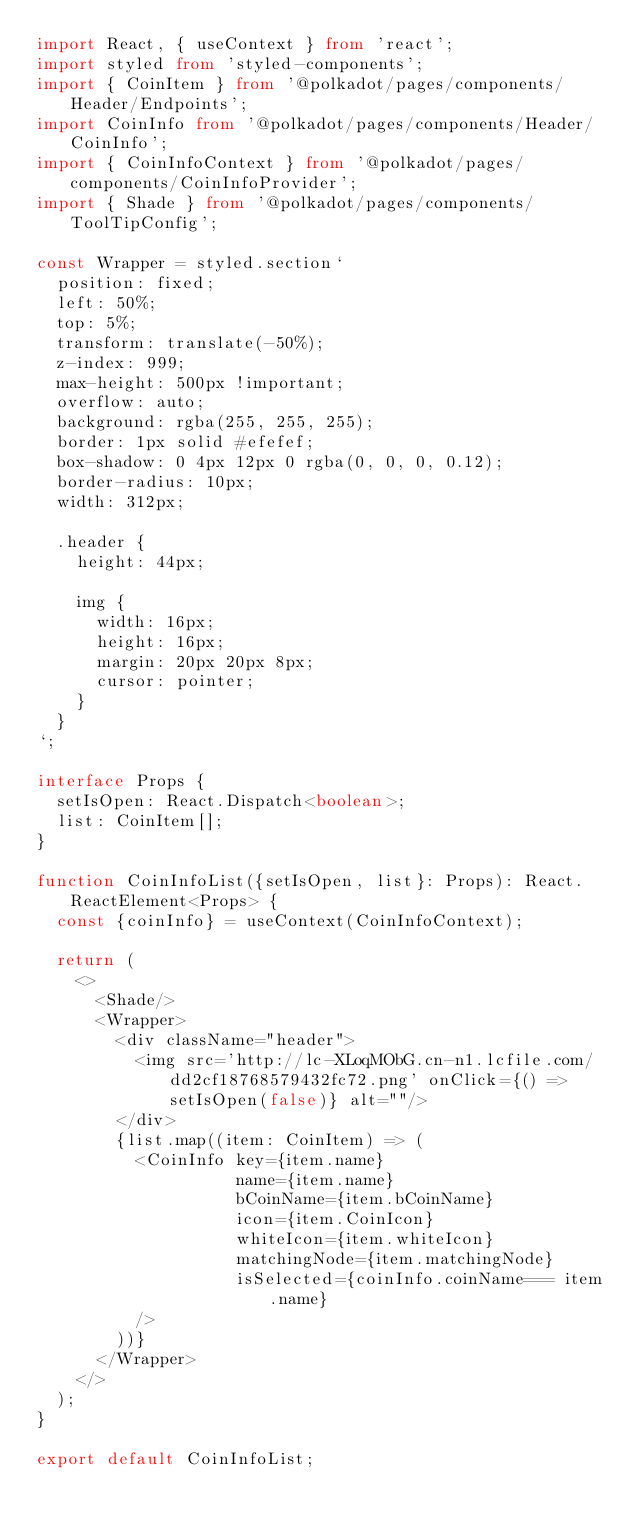<code> <loc_0><loc_0><loc_500><loc_500><_TypeScript_>import React, { useContext } from 'react';
import styled from 'styled-components';
import { CoinItem } from '@polkadot/pages/components/Header/Endpoints';
import CoinInfo from '@polkadot/pages/components/Header/CoinInfo';
import { CoinInfoContext } from '@polkadot/pages/components/CoinInfoProvider';
import { Shade } from '@polkadot/pages/components/ToolTipConfig';

const Wrapper = styled.section`
  position: fixed;
  left: 50%;
  top: 5%;
  transform: translate(-50%);
  z-index: 999;
  max-height: 500px !important;
  overflow: auto;
  background: rgba(255, 255, 255);
  border: 1px solid #efefef;
  box-shadow: 0 4px 12px 0 rgba(0, 0, 0, 0.12);
  border-radius: 10px;
  width: 312px;

  .header {
    height: 44px;

    img {
      width: 16px;
      height: 16px;
      margin: 20px 20px 8px;
      cursor: pointer;
    }
  }
`;

interface Props {
  setIsOpen: React.Dispatch<boolean>;
  list: CoinItem[];
}

function CoinInfoList({setIsOpen, list}: Props): React.ReactElement<Props> {
  const {coinInfo} = useContext(CoinInfoContext);

  return (
    <>
      <Shade/>
      <Wrapper>
        <div className="header">
          <img src='http://lc-XLoqMObG.cn-n1.lcfile.com/dd2cf18768579432fc72.png' onClick={() => setIsOpen(false)} alt=""/>
        </div>
        {list.map((item: CoinItem) => (
          <CoinInfo key={item.name}
                    name={item.name}
                    bCoinName={item.bCoinName}
                    icon={item.CoinIcon}
                    whiteIcon={item.whiteIcon}
                    matchingNode={item.matchingNode}
                    isSelected={coinInfo.coinName=== item.name}
          />
        ))}
      </Wrapper>
    </>
  );
}

export default CoinInfoList;
</code> 